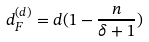Convert formula to latex. <formula><loc_0><loc_0><loc_500><loc_500>d ^ { ( d ) } _ { F } = d ( 1 - \frac { n } { \delta + 1 } )</formula> 